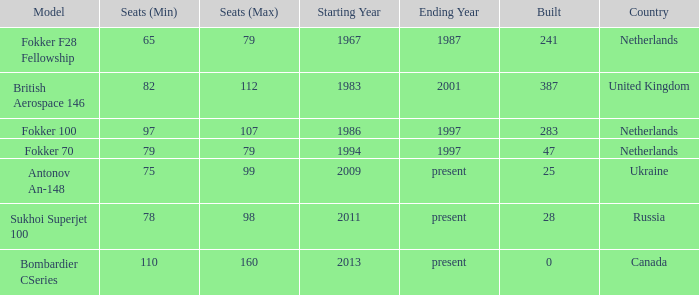How many cabins were built in the time between 1967-1987? 241.0. 